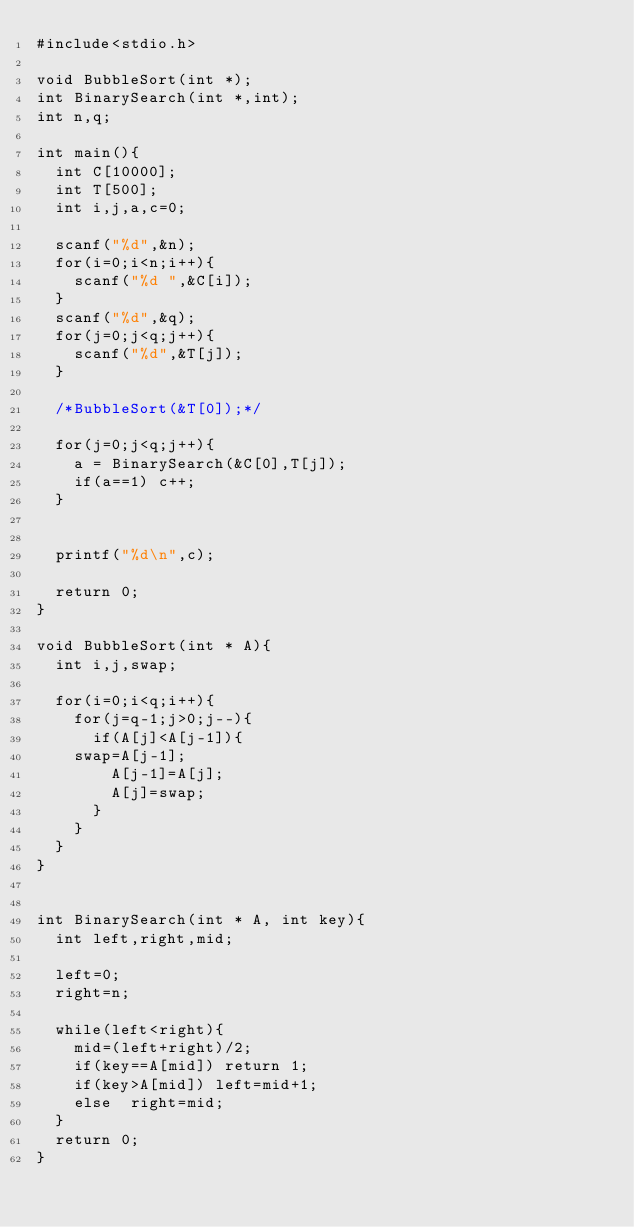Convert code to text. <code><loc_0><loc_0><loc_500><loc_500><_C_>#include<stdio.h>

void BubbleSort(int *);
int BinarySearch(int *,int);
int n,q;

int main(){
  int C[10000];
  int T[500];
  int i,j,a,c=0;

  scanf("%d",&n);
  for(i=0;i<n;i++){
    scanf("%d ",&C[i]);
  }
  scanf("%d",&q);
  for(j=0;j<q;j++){
    scanf("%d",&T[j]);
  }

  /*BubbleSort(&T[0]);*/
     
  for(j=0;j<q;j++){
    a = BinarySearch(&C[0],T[j]);
    if(a==1) c++;
  }

 
  printf("%d\n",c);

  return 0;
}

void BubbleSort(int * A){
  int i,j,swap;

  for(i=0;i<q;i++){
    for(j=q-1;j>0;j--){
      if(A[j]<A[j-1]){
	swap=A[j-1];
        A[j-1]=A[j];
        A[j]=swap;
      }
    }
  }
}
 

int BinarySearch(int * A, int key){
  int left,right,mid; 
 
  left=0;
  right=n;

  while(left<right){
    mid=(left+right)/2;
    if(key==A[mid]) return 1;
    if(key>A[mid]) left=mid+1;
    else  right=mid;
  }
  return 0;
}
  </code> 